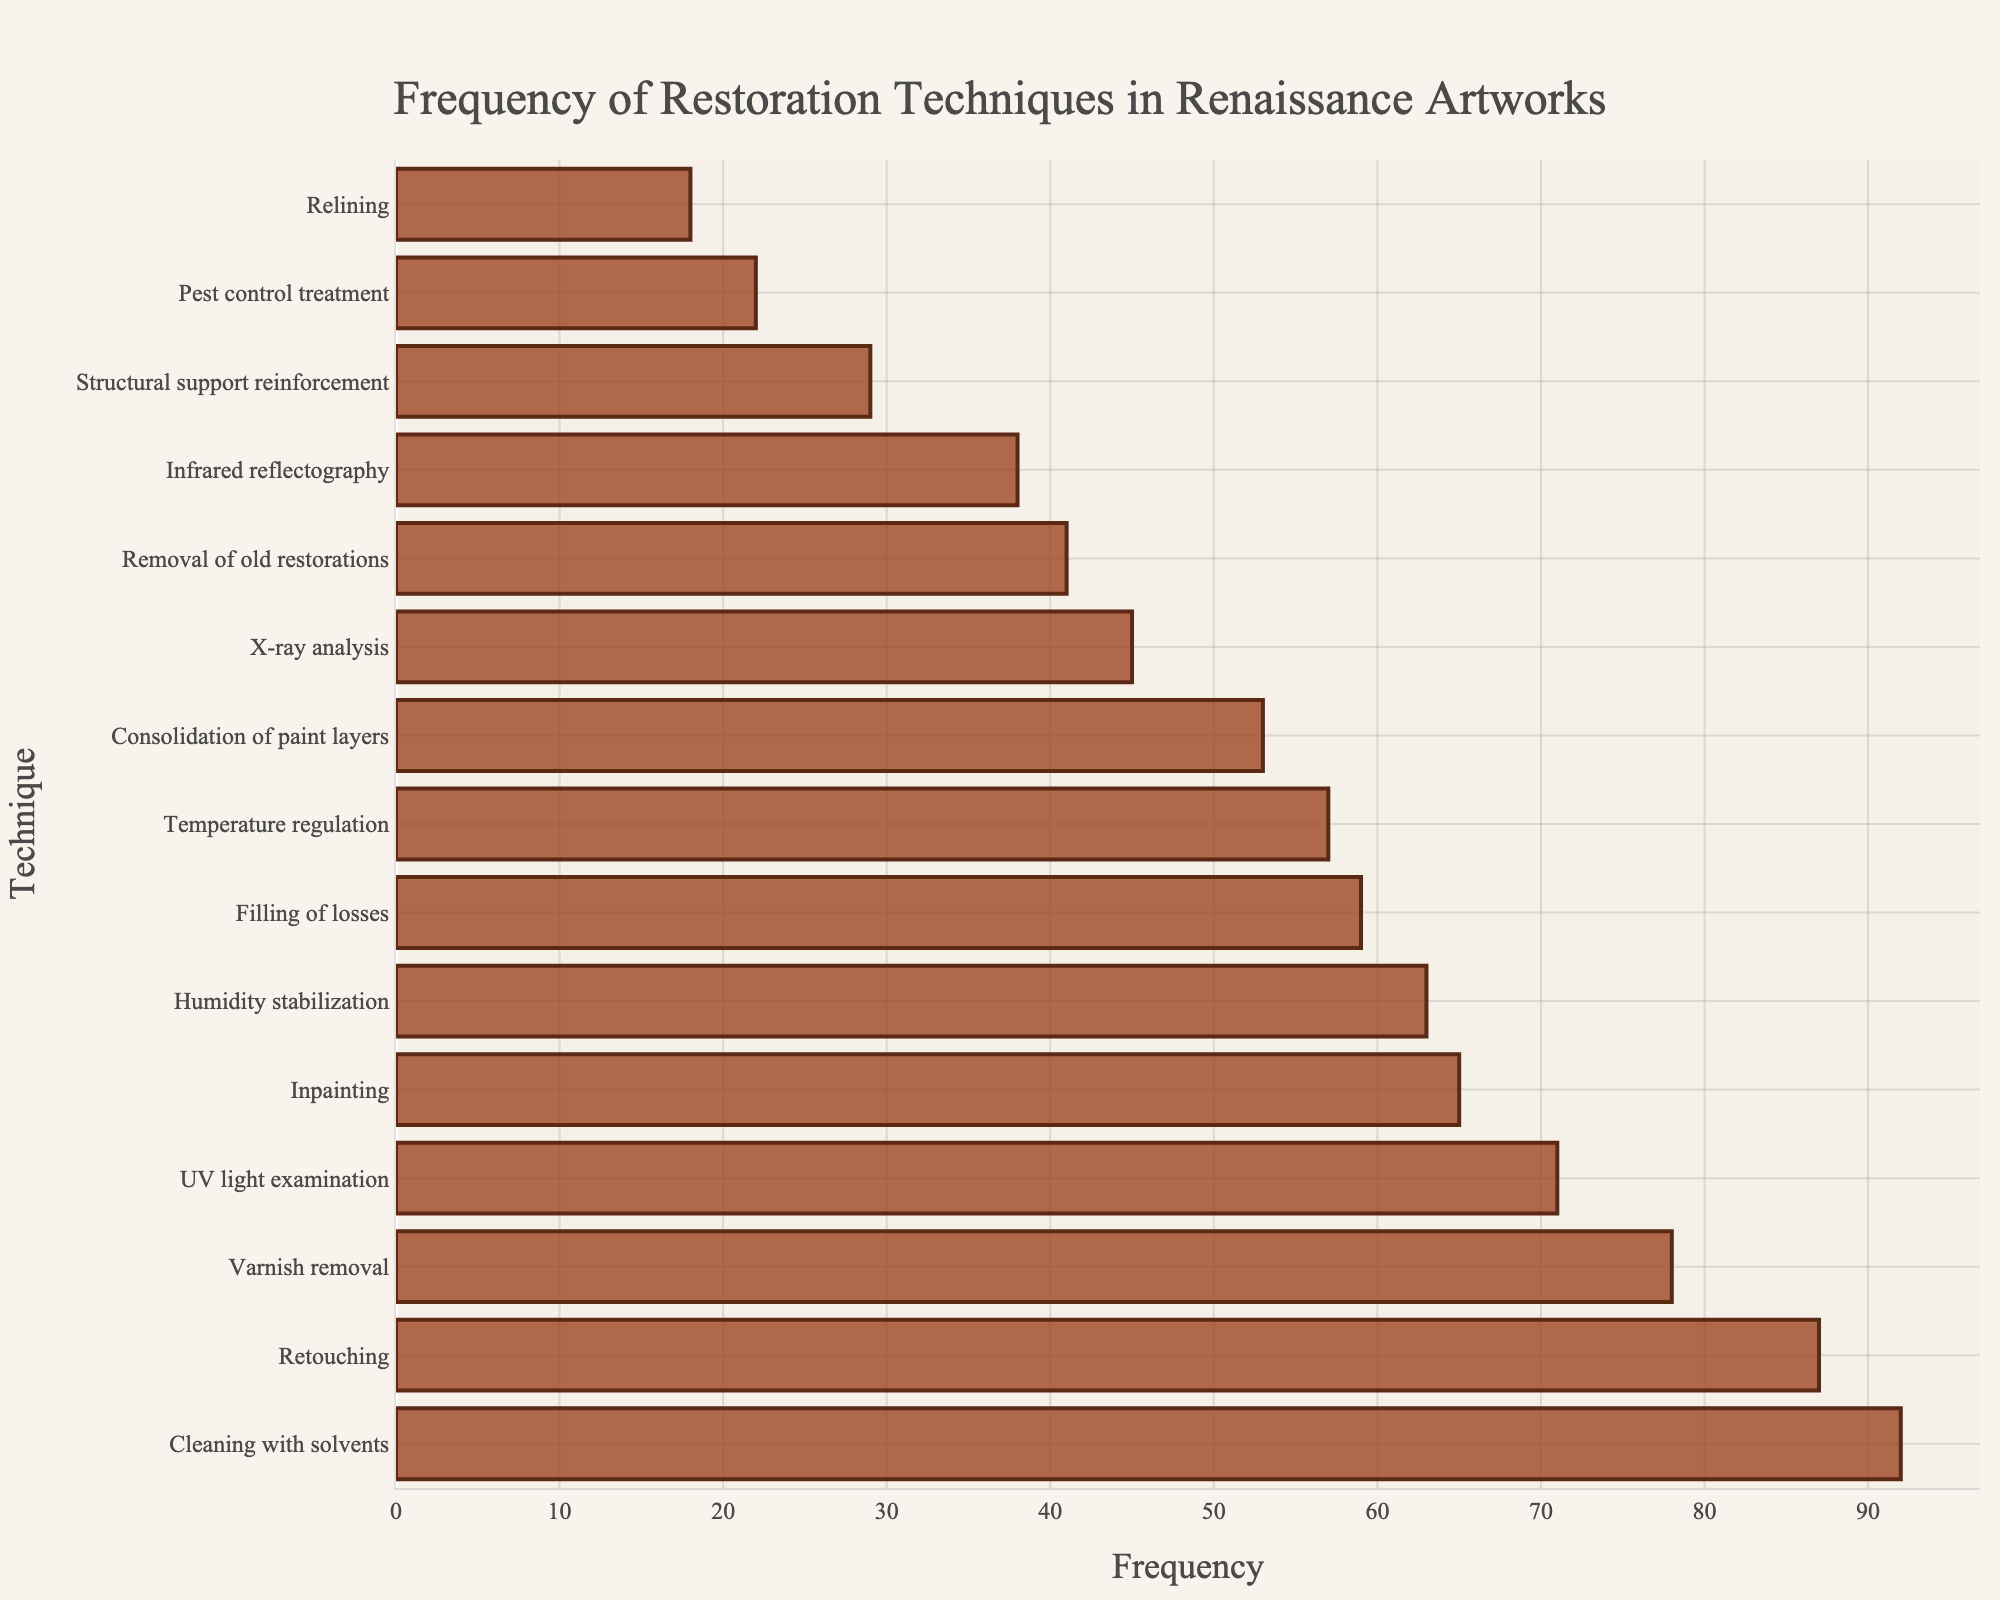What is the most frequently applied restoration technique? The most frequently applied technique is the one with the tallest bar in the bar chart. "Cleaning with solvents" has the highest frequency at 92.
Answer: Cleaning with solvents Which two techniques have the closest frequencies? To find the two techniques with the closest frequencies, we look for bars of nearly equal length. "Infrared reflectography" (38) and "Removal of old restorations" (41) are the closest, with a difference of 3.
Answer: Infrared reflectography and Removal of old restorations How much more frequently is "Retouching" applied compared to "Structural support reinforcement"? Find the difference in frequency between "Retouching" (87) and "Structural support reinforcement" (29). Calculate: 87 - 29 = 58.
Answer: 58 What's the average frequency of "Inpainting," "Filling of losses," and "Temperature regulation"? Sum the frequencies of "Inpainting" (65), "Filling of losses" (59), and "Temperature regulation" (57), and divide by 3. Calculate: (65 + 59 + 57) / 3 ≈ 60.33.
Answer: 60.33 Which is more frequently applied: "Humidity stabilization" or "UV light examination"? Compare the lengths of the bars for "Humidity stabilization" (63) and "UV light examination" (71). "UV light examination" has a higher frequency.
Answer: UV light examination How many techniques have a frequency greater than 60? Count the number of bars with lengths extending past the 60 mark. The techniques are "Cleaning with solvents" (92), "Retouching" (87), "Varnish removal" (78), "UV light examination" (71), and "Humidity stabilization" (63), totaling 5.
Answer: 5 Which technique has the median frequency value? Sort the frequencies in ascending order and find the middle value. With 14 data points, the median is the average of the 7th and 8th frequencies. After sorting: (41+45)/2 = 43. The technique near this frequency is "X-ray analysis" (45).
Answer: X-ray analysis What is the combined frequency of "Varnish removal" and "Consolidation of paint layers"? Add the frequencies of "Varnish removal" (78) and "Consolidation of paint layers" (53). Calculate: 78 + 53 = 131.
Answer: 131 